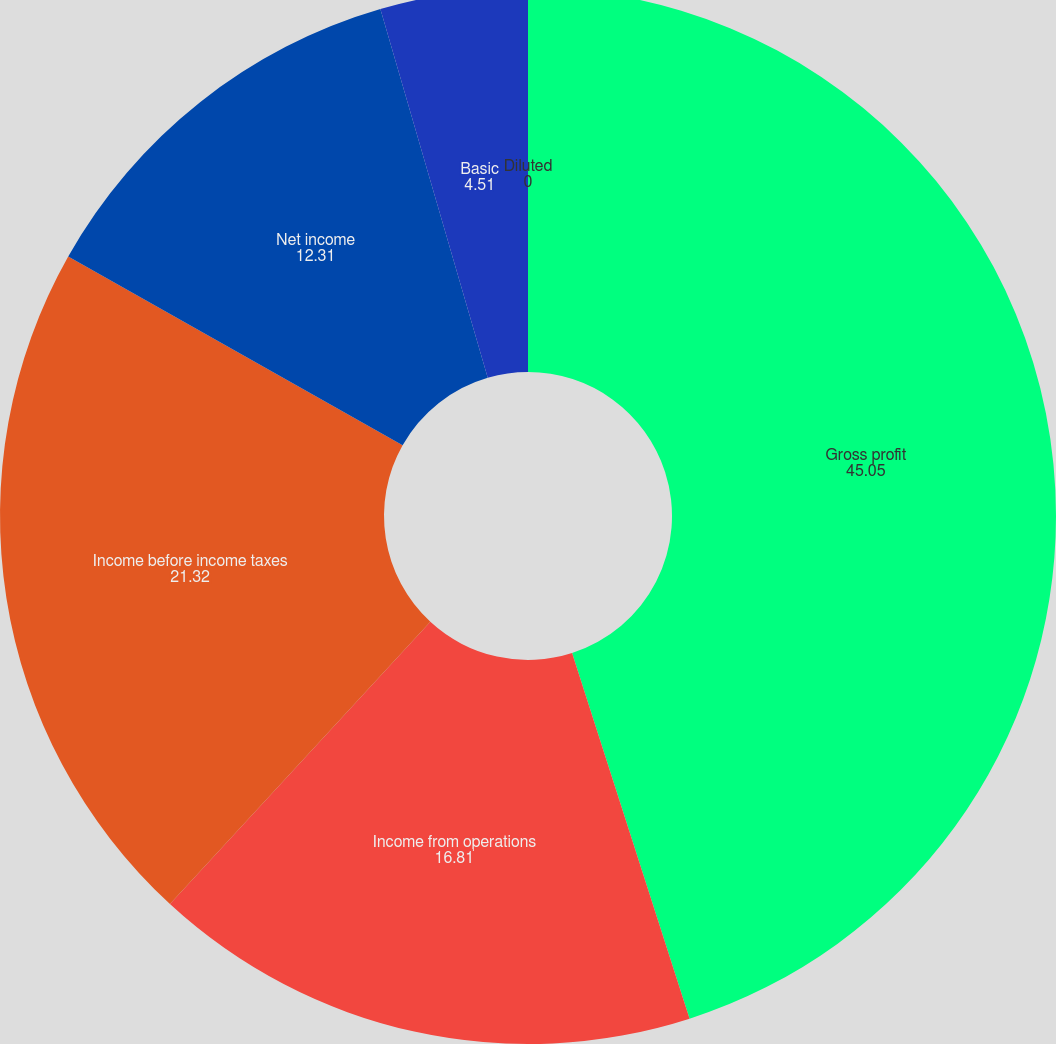Convert chart. <chart><loc_0><loc_0><loc_500><loc_500><pie_chart><fcel>Gross profit<fcel>Income from operations<fcel>Income before income taxes<fcel>Net income<fcel>Basic<fcel>Diluted<nl><fcel>45.05%<fcel>16.81%<fcel>21.32%<fcel>12.31%<fcel>4.51%<fcel>0.0%<nl></chart> 